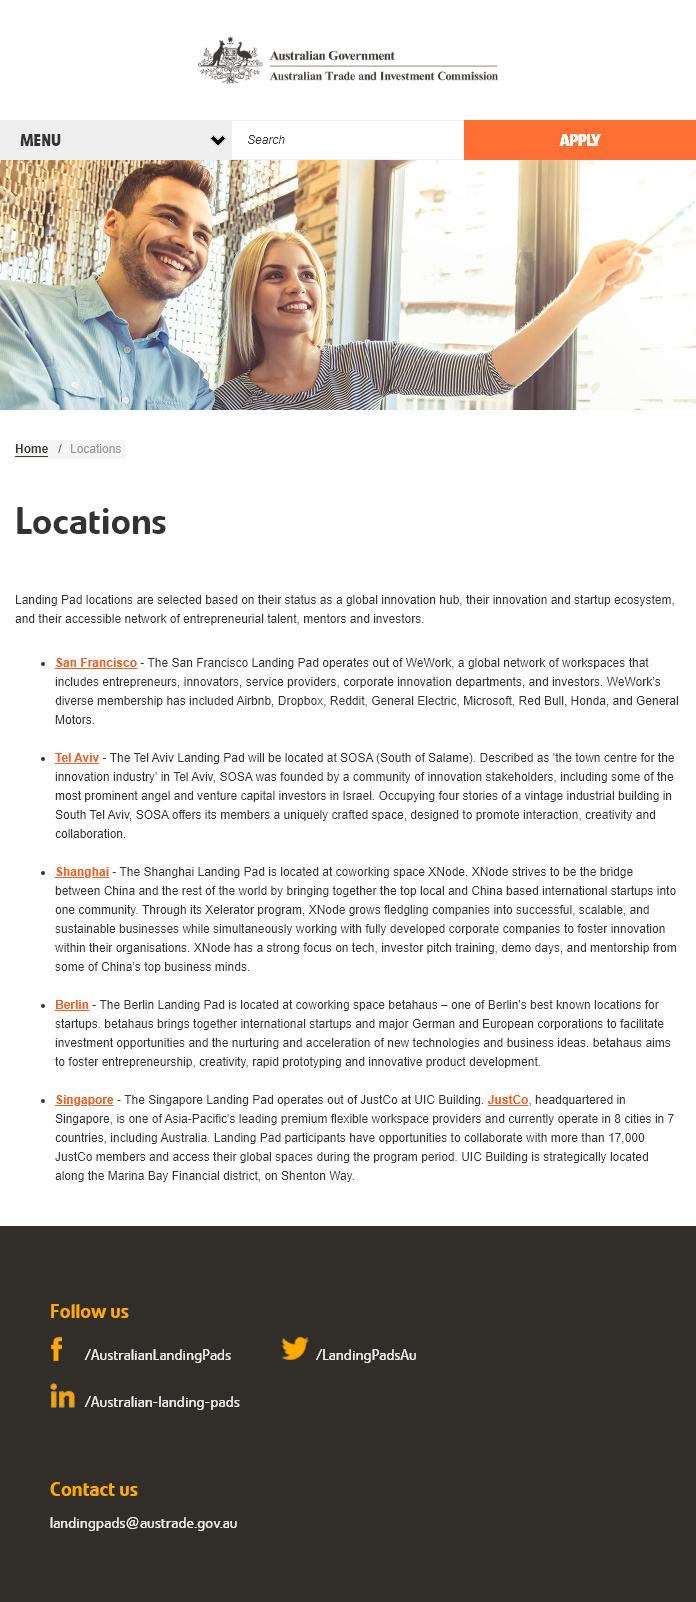Highlight a few significant elements in this photo. The San Francisco Landing Pad operates out of WeWork. SOSA stands for South of Salame. It is a location in the southern region. The two locations designated as landing pads are San Francisco and Tel Aviv, providing a foundation for the success of the project. 